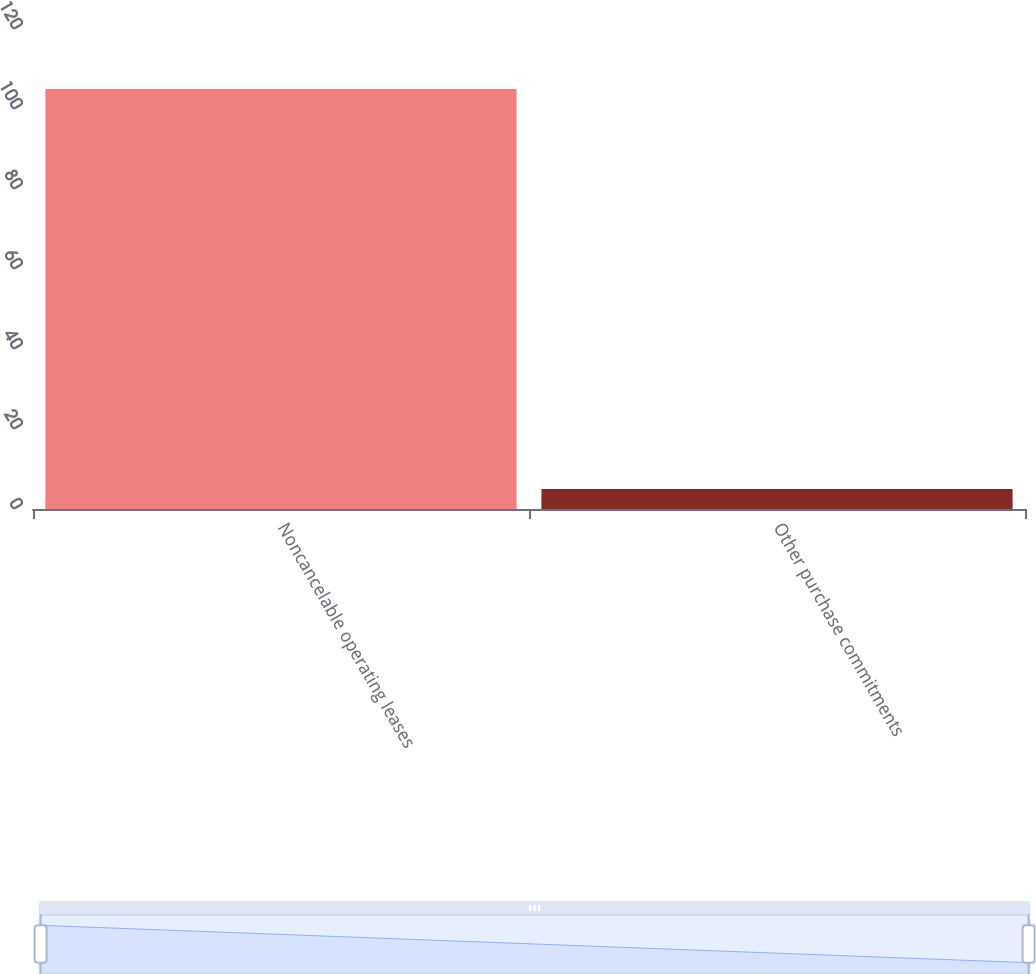Convert chart. <chart><loc_0><loc_0><loc_500><loc_500><bar_chart><fcel>Noncancelable operating leases<fcel>Other purchase commitments<nl><fcel>105<fcel>5<nl></chart> 